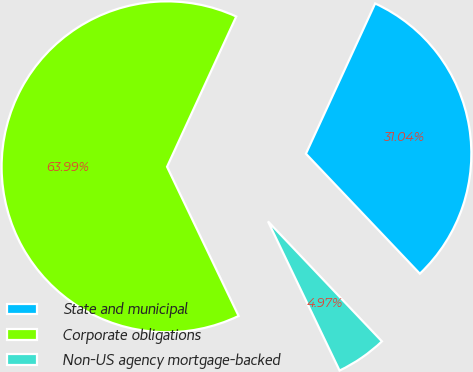<chart> <loc_0><loc_0><loc_500><loc_500><pie_chart><fcel>State and municipal<fcel>Corporate obligations<fcel>Non-US agency mortgage-backed<nl><fcel>31.04%<fcel>63.99%<fcel>4.97%<nl></chart> 